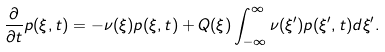<formula> <loc_0><loc_0><loc_500><loc_500>\frac { \partial } { \partial t } p ( \xi , t ) = - \nu ( \xi ) p ( \xi , t ) + Q ( \xi ) \int _ { - \infty } ^ { \infty } \nu ( \xi ^ { \prime } ) p ( \xi ^ { \prime } , t ) d \xi ^ { \prime } .</formula> 